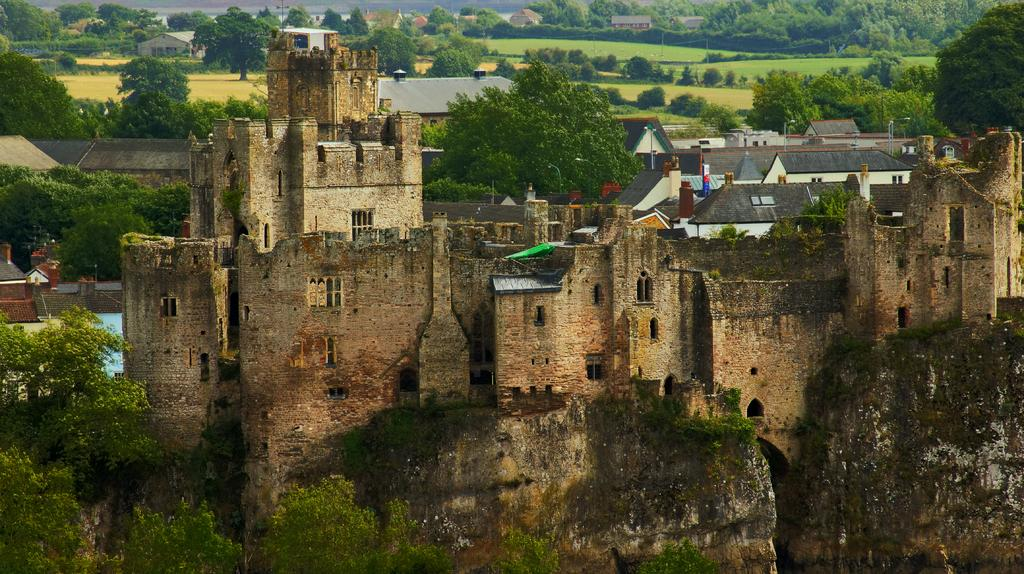What type of structures can be seen in the image? There are buildings and houses in the image. What can be seen in the background of the image? There are trees in the background of the image. What is on the ground in the image? There is grass on the ground in the image. What is located in the front of the image? There are trees in the front of the image. What type of underwear is hanging on the hook in the image? There is no underwear or hook present in the image. How many steps are visible in the image? There are no steps visible in the image. 